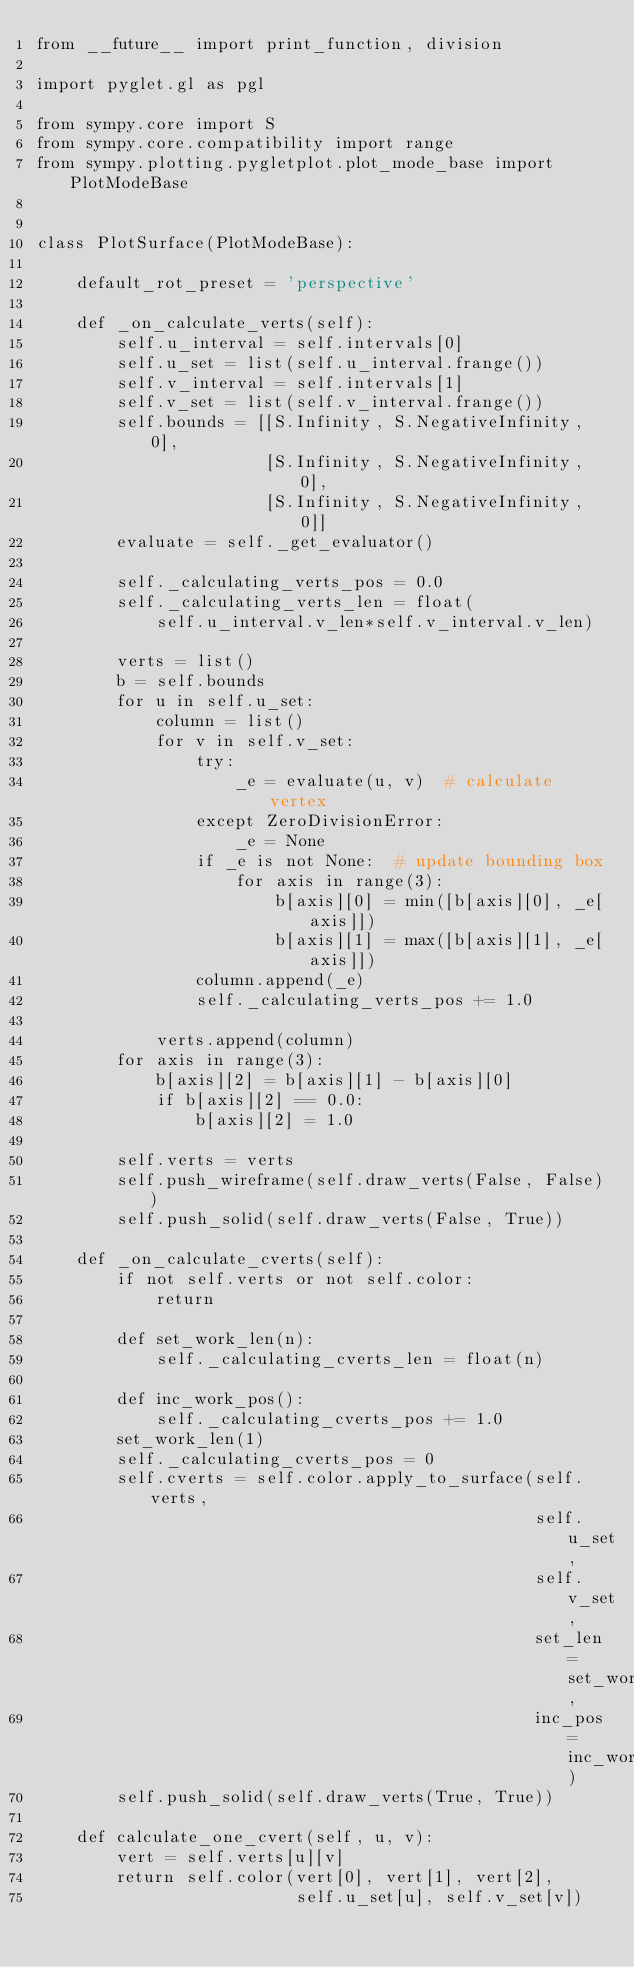<code> <loc_0><loc_0><loc_500><loc_500><_Python_>from __future__ import print_function, division

import pyglet.gl as pgl

from sympy.core import S
from sympy.core.compatibility import range
from sympy.plotting.pygletplot.plot_mode_base import PlotModeBase


class PlotSurface(PlotModeBase):

    default_rot_preset = 'perspective'

    def _on_calculate_verts(self):
        self.u_interval = self.intervals[0]
        self.u_set = list(self.u_interval.frange())
        self.v_interval = self.intervals[1]
        self.v_set = list(self.v_interval.frange())
        self.bounds = [[S.Infinity, S.NegativeInfinity, 0],
                       [S.Infinity, S.NegativeInfinity, 0],
                       [S.Infinity, S.NegativeInfinity, 0]]
        evaluate = self._get_evaluator()

        self._calculating_verts_pos = 0.0
        self._calculating_verts_len = float(
            self.u_interval.v_len*self.v_interval.v_len)

        verts = list()
        b = self.bounds
        for u in self.u_set:
            column = list()
            for v in self.v_set:
                try:
                    _e = evaluate(u, v)  # calculate vertex
                except ZeroDivisionError:
                    _e = None
                if _e is not None:  # update bounding box
                    for axis in range(3):
                        b[axis][0] = min([b[axis][0], _e[axis]])
                        b[axis][1] = max([b[axis][1], _e[axis]])
                column.append(_e)
                self._calculating_verts_pos += 1.0

            verts.append(column)
        for axis in range(3):
            b[axis][2] = b[axis][1] - b[axis][0]
            if b[axis][2] == 0.0:
                b[axis][2] = 1.0

        self.verts = verts
        self.push_wireframe(self.draw_verts(False, False))
        self.push_solid(self.draw_verts(False, True))

    def _on_calculate_cverts(self):
        if not self.verts or not self.color:
            return

        def set_work_len(n):
            self._calculating_cverts_len = float(n)

        def inc_work_pos():
            self._calculating_cverts_pos += 1.0
        set_work_len(1)
        self._calculating_cverts_pos = 0
        self.cverts = self.color.apply_to_surface(self.verts,
                                                  self.u_set,
                                                  self.v_set,
                                                  set_len=set_work_len,
                                                  inc_pos=inc_work_pos)
        self.push_solid(self.draw_verts(True, True))

    def calculate_one_cvert(self, u, v):
        vert = self.verts[u][v]
        return self.color(vert[0], vert[1], vert[2],
                          self.u_set[u], self.v_set[v])
</code> 